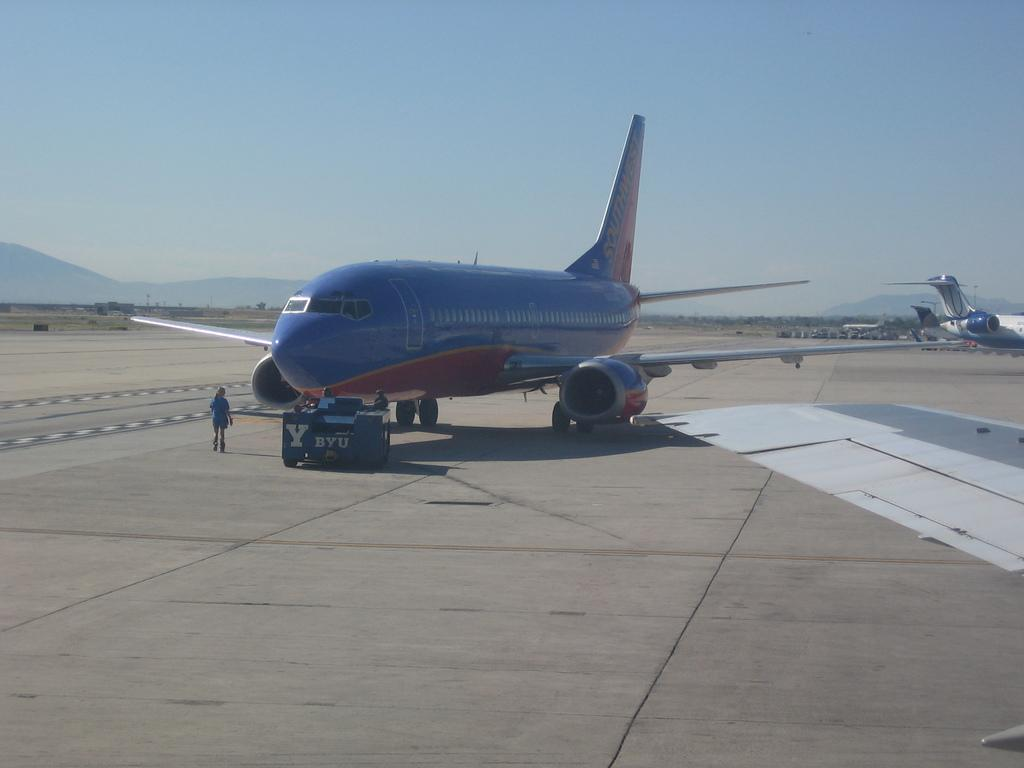<image>
Create a compact narrative representing the image presented. A Southwest plane waits on the runway with other planes. 